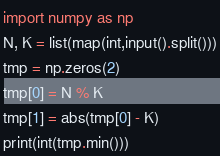<code> <loc_0><loc_0><loc_500><loc_500><_Python_>import numpy as np
N, K = list(map(int,input().split()))
tmp = np.zeros(2)
tmp[0] = N % K
tmp[1] = abs(tmp[0] - K)
print(int(tmp.min()))</code> 